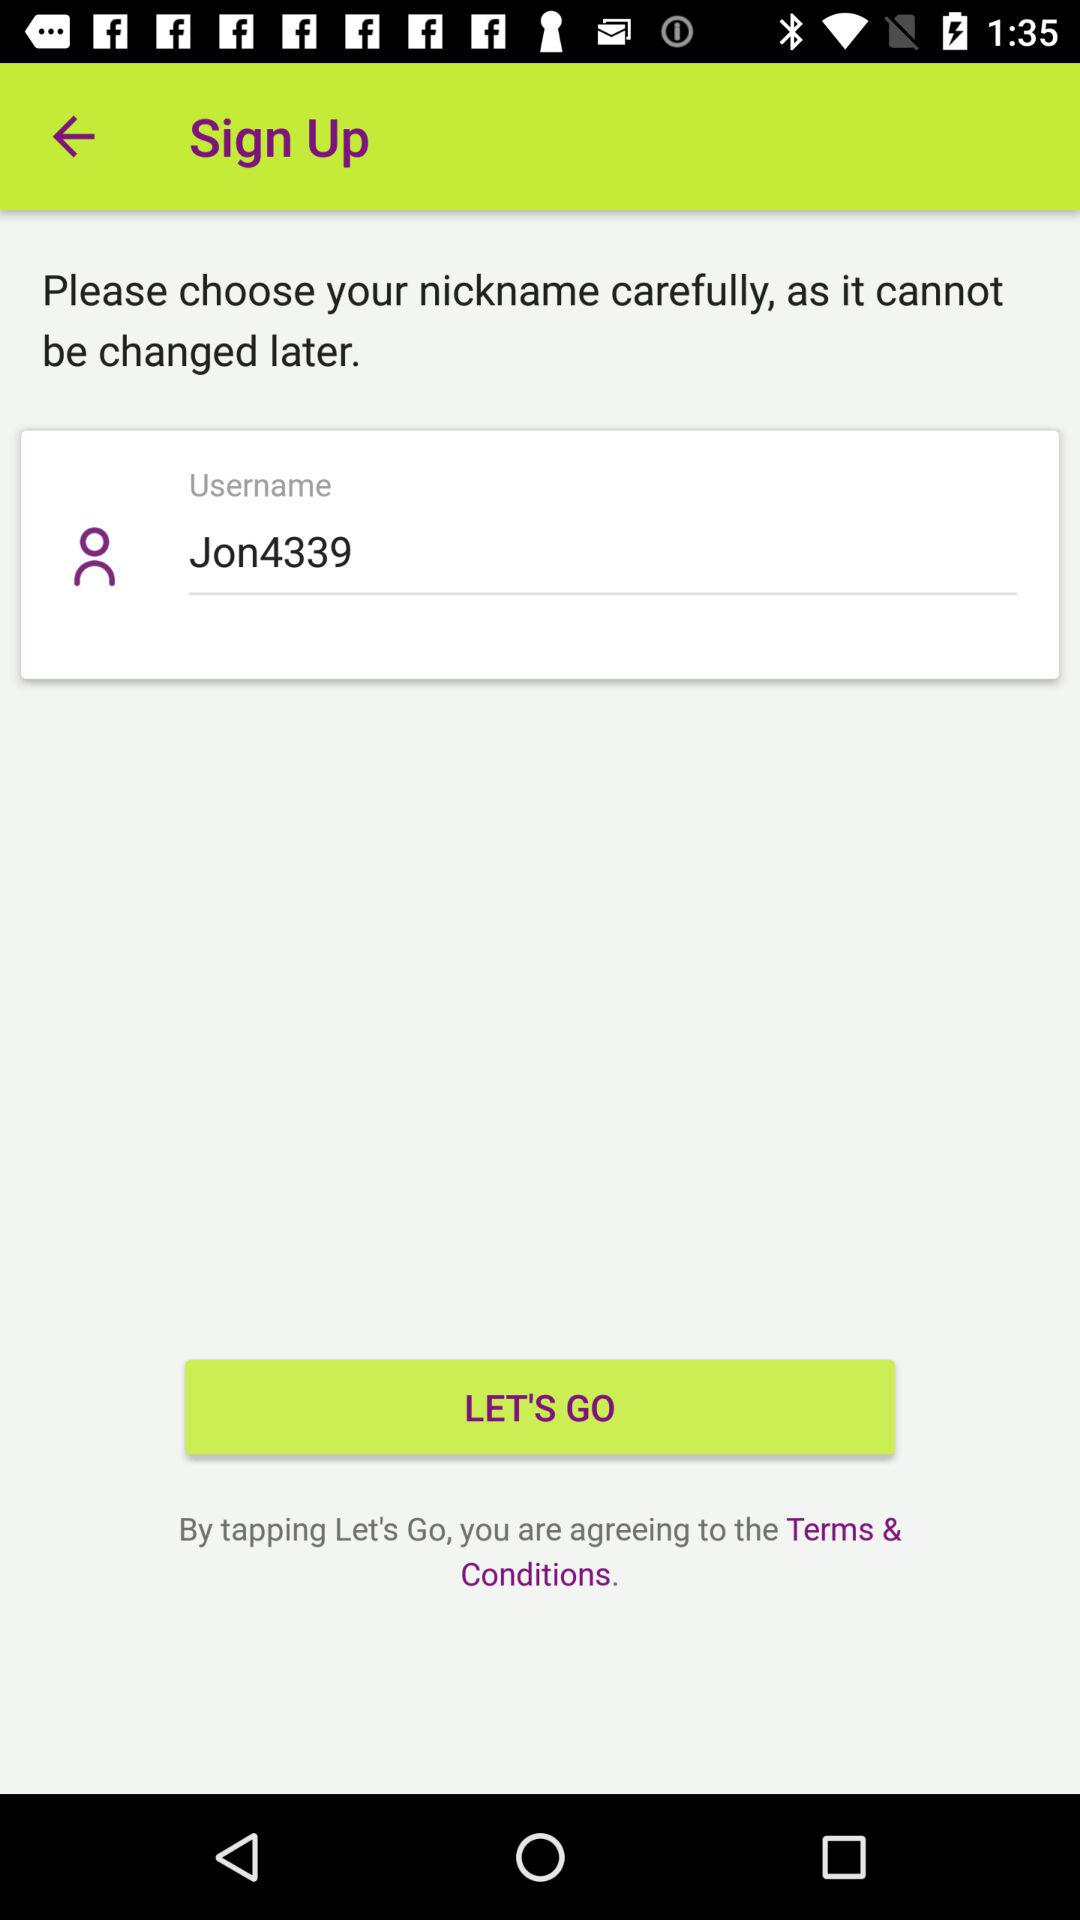What is the user name? The user name is "Jon4339". 